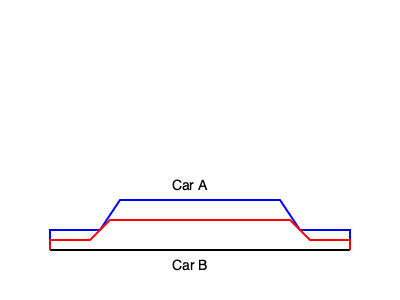Based on the side profiles of two car models shown above, which car has a greater overall length? How does the height of Car A compare to Car B? To compare the dimensions of the two car models, we need to analyze their side profiles:

1. Length comparison:
   - Both cars start at the same point on the left (x = 50).
   - Both cars end at the same point on the right (x = 350).
   - Therefore, the overall length of both cars is equal.

2. Height comparison:
   - Car A (blue profile) has its roof line at y = 200.
   - Car B (red profile) has its roof line at y = 220.
   - The y-axis is inverted in SVG, with lower values being higher on the image.
   - This means Car A's roof is higher than Car B's roof.

3. Overall shape:
   - Car A has a more pronounced curve from the hood to the roof.
   - Car B has a flatter, more streamlined profile.

From this analysis, we can conclude that while both cars have the same length, Car A is taller than Car B.
Answer: Same length; Car A is taller 